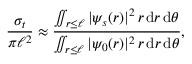<formula> <loc_0><loc_0><loc_500><loc_500>\frac { \sigma _ { t } } { \pi \ell ^ { 2 } } \approx \frac { \iint _ { r \leq \ell } | \psi _ { s } ( r ) | ^ { 2 } \, r \, d r \, d \theta } { \iint _ { r \leq \ell } | \psi _ { 0 } ( r ) | ^ { 2 } \, r \, d r \, d \theta } ,</formula> 